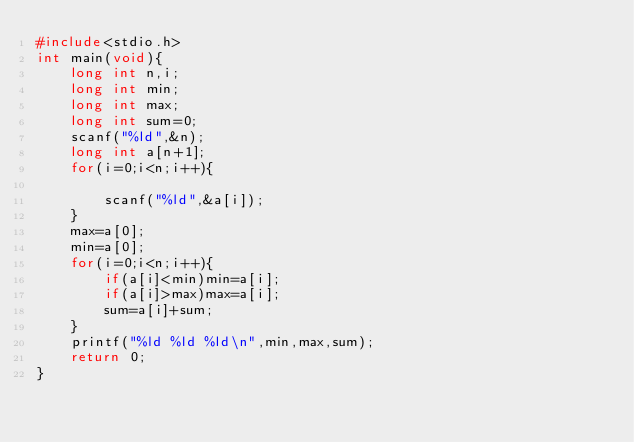Convert code to text. <code><loc_0><loc_0><loc_500><loc_500><_C_>#include<stdio.h>
int main(void){
    long int n,i;
    long int min;
    long int max;
    long int sum=0;
    scanf("%ld",&n);
    long int a[n+1];
    for(i=0;i<n;i++){
        
        scanf("%ld",&a[i]);
    }
    max=a[0];
    min=a[0];
    for(i=0;i<n;i++){
        if(a[i]<min)min=a[i];
        if(a[i]>max)max=a[i];
        sum=a[i]+sum;
    }
    printf("%ld %ld %ld\n",min,max,sum);
    return 0;
}
</code> 